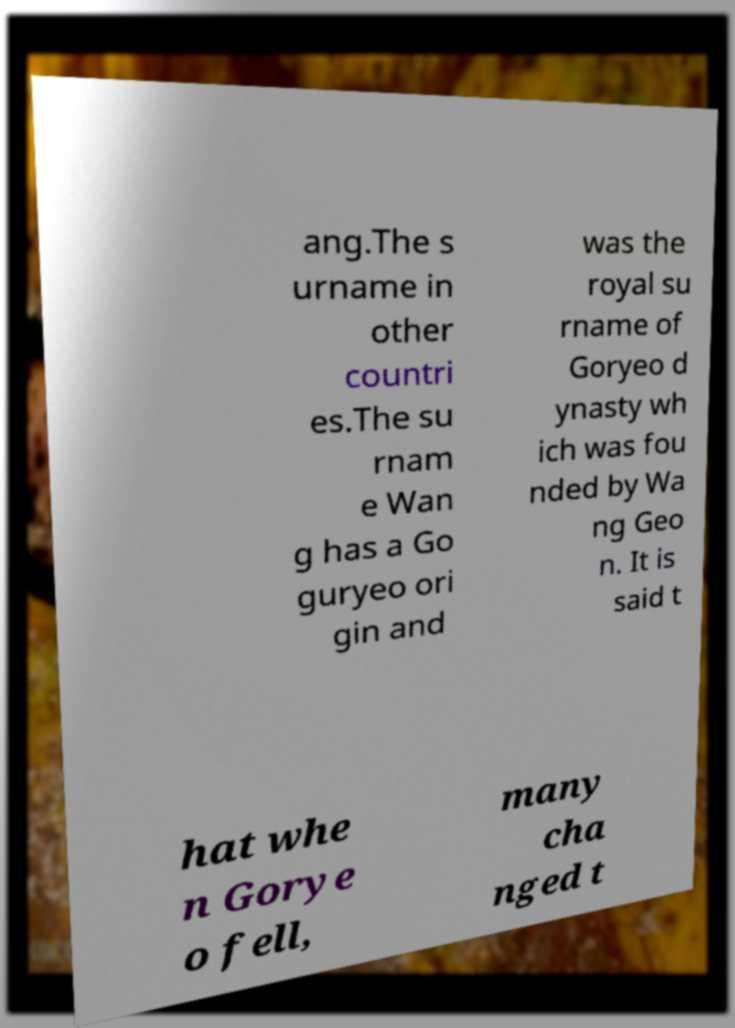For documentation purposes, I need the text within this image transcribed. Could you provide that? ang.The s urname in other countri es.The su rnam e Wan g has a Go guryeo ori gin and was the royal su rname of Goryeo d ynasty wh ich was fou nded by Wa ng Geo n. It is said t hat whe n Gorye o fell, many cha nged t 